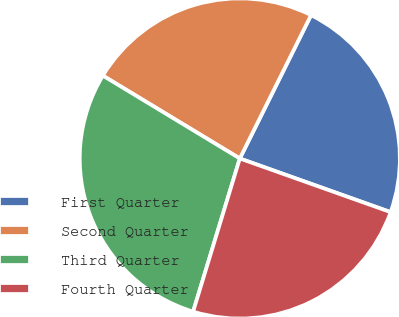Convert chart to OTSL. <chart><loc_0><loc_0><loc_500><loc_500><pie_chart><fcel>First Quarter<fcel>Second Quarter<fcel>Third Quarter<fcel>Fourth Quarter<nl><fcel>23.1%<fcel>23.68%<fcel>28.95%<fcel>24.27%<nl></chart> 